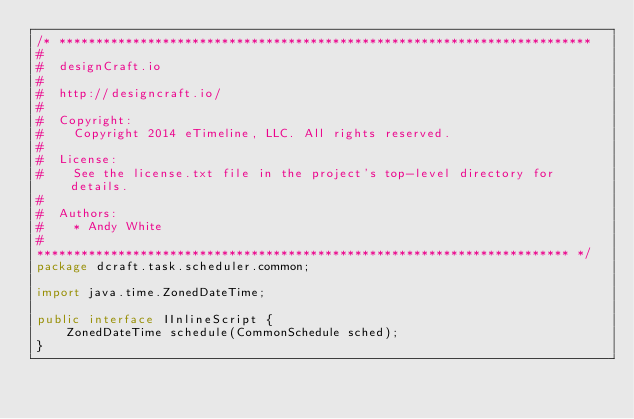<code> <loc_0><loc_0><loc_500><loc_500><_Java_>/* ************************************************************************
#
#  designCraft.io
#
#  http://designcraft.io/
#
#  Copyright:
#    Copyright 2014 eTimeline, LLC. All rights reserved.
#
#  License:
#    See the license.txt file in the project's top-level directory for details.
#
#  Authors:
#    * Andy White
#
************************************************************************ */
package dcraft.task.scheduler.common;

import java.time.ZonedDateTime;

public interface IInlineScript {
	ZonedDateTime schedule(CommonSchedule sched);
}
</code> 